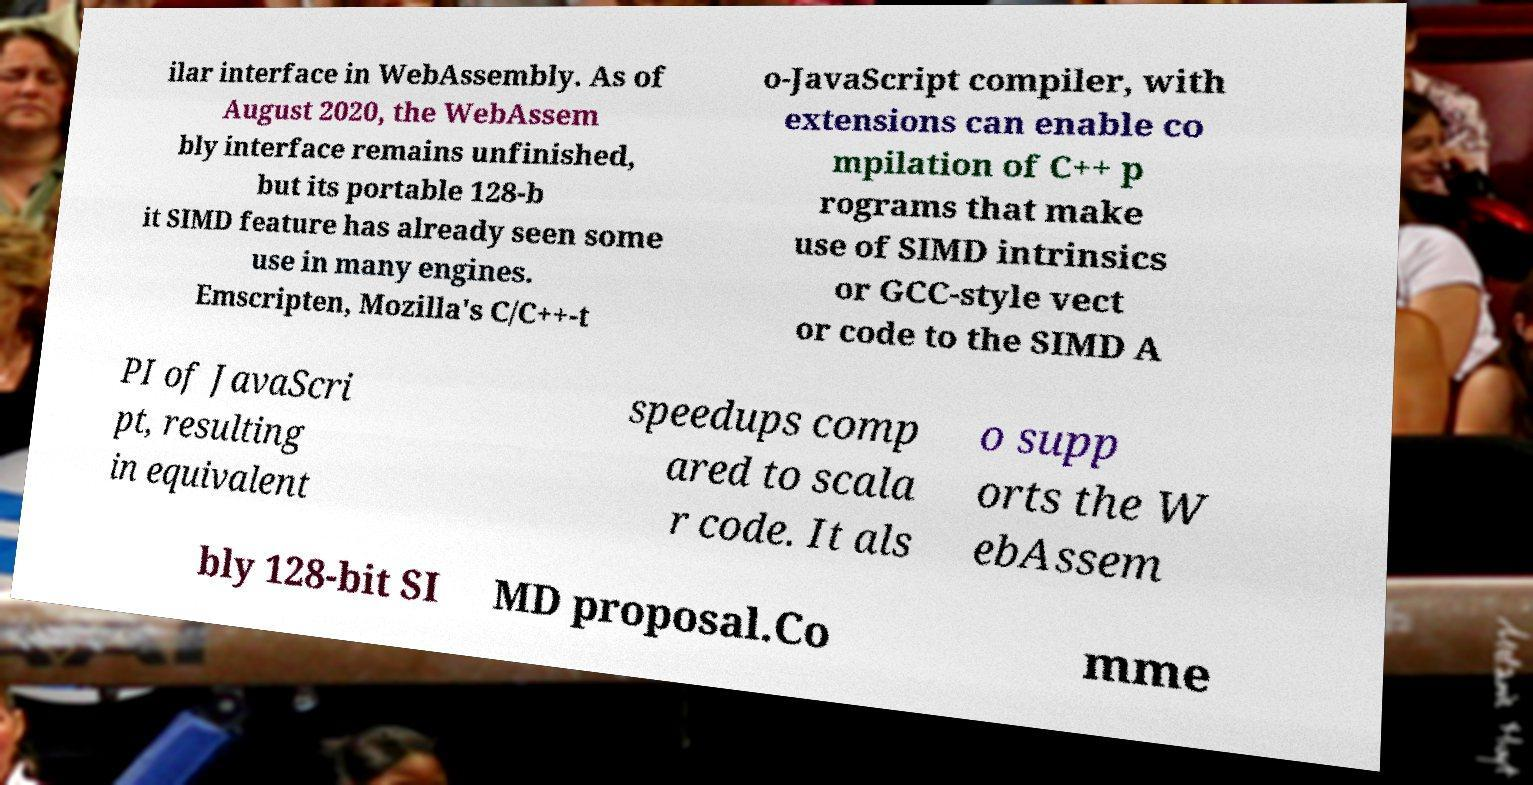Please identify and transcribe the text found in this image. ilar interface in WebAssembly. As of August 2020, the WebAssem bly interface remains unfinished, but its portable 128-b it SIMD feature has already seen some use in many engines. Emscripten, Mozilla's C/C++-t o-JavaScript compiler, with extensions can enable co mpilation of C++ p rograms that make use of SIMD intrinsics or GCC-style vect or code to the SIMD A PI of JavaScri pt, resulting in equivalent speedups comp ared to scala r code. It als o supp orts the W ebAssem bly 128-bit SI MD proposal.Co mme 